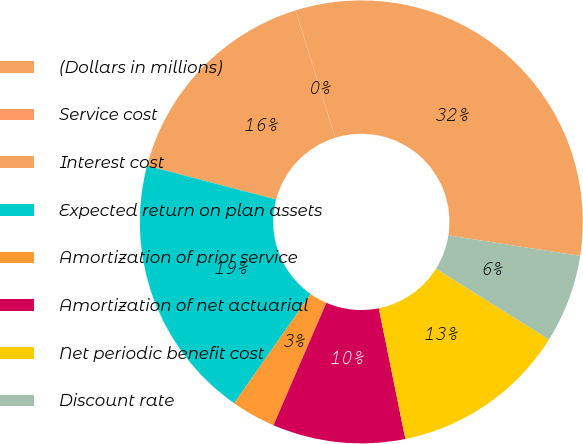Convert chart. <chart><loc_0><loc_0><loc_500><loc_500><pie_chart><fcel>(Dollars in millions)<fcel>Service cost<fcel>Interest cost<fcel>Expected return on plan assets<fcel>Amortization of prior service<fcel>Amortization of net actuarial<fcel>Net periodic benefit cost<fcel>Discount rate<nl><fcel>32.23%<fcel>0.02%<fcel>16.12%<fcel>19.35%<fcel>3.24%<fcel>9.68%<fcel>12.9%<fcel>6.46%<nl></chart> 